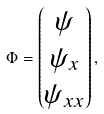<formula> <loc_0><loc_0><loc_500><loc_500>\Phi = \begin{pmatrix} \psi \\ \psi _ { x } \\ \psi _ { x x } \end{pmatrix} ,</formula> 